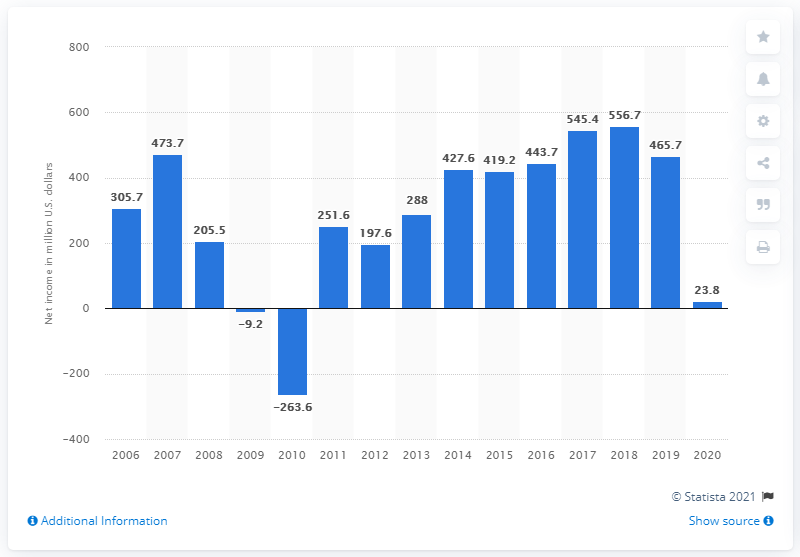Identify some key points in this picture. The net income of Manpower Group in the previous year was $465.7 million. In 2020, Manpower Group made approximately 23.8 billion U.S. dollars in revenue. 